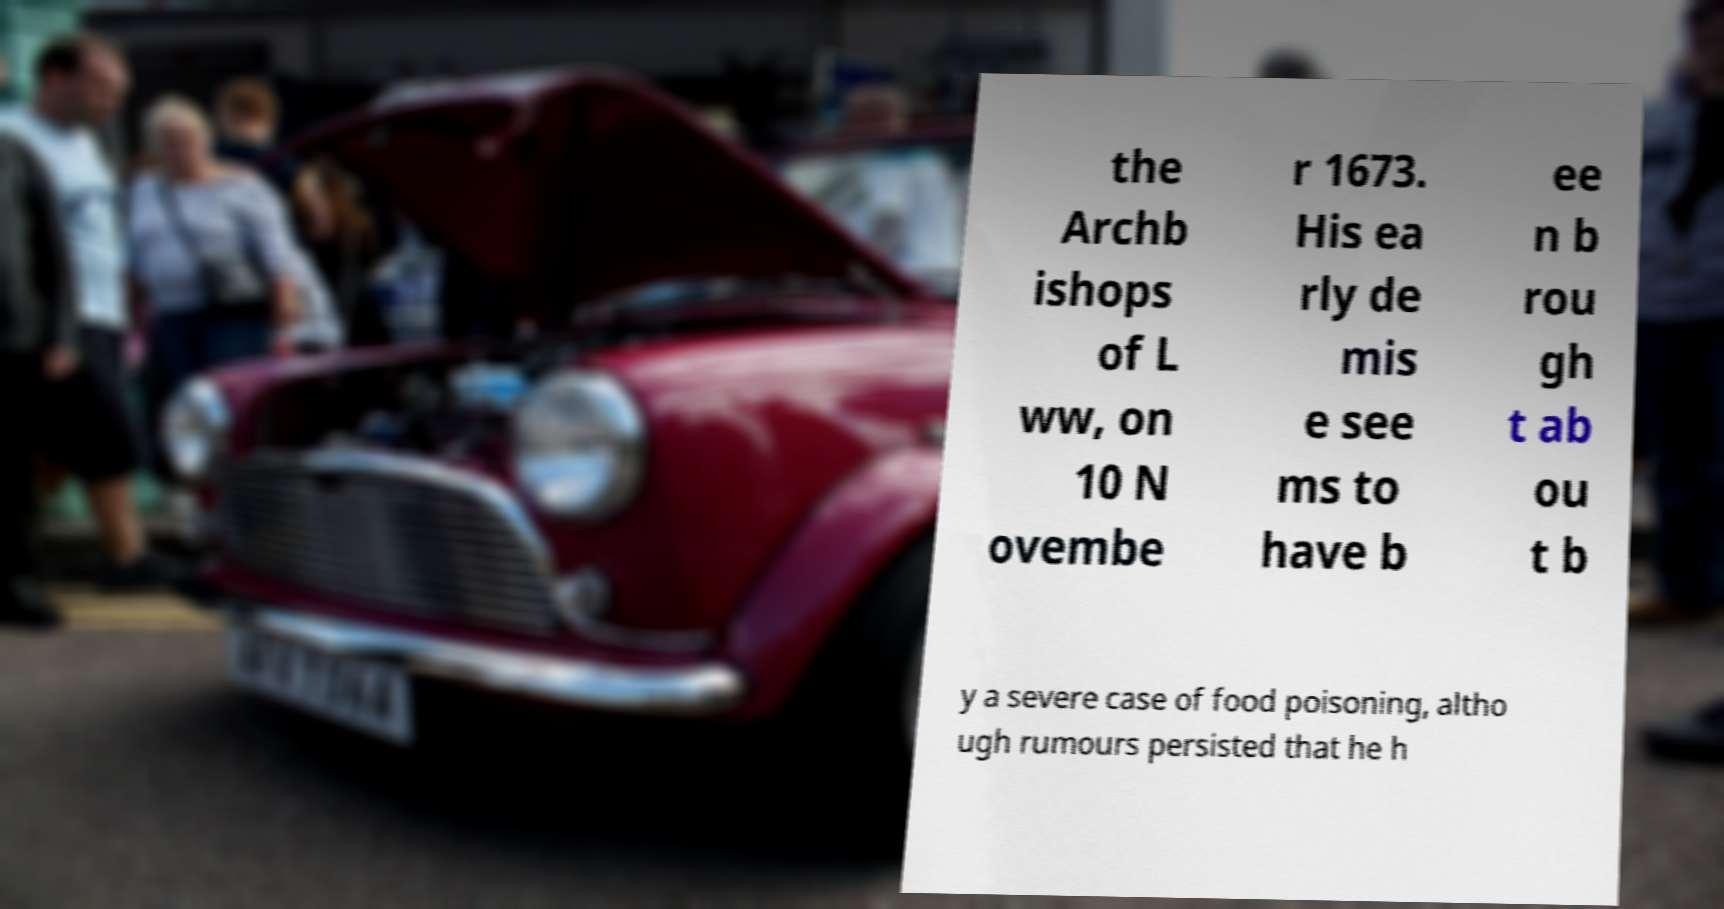Please read and relay the text visible in this image. What does it say? the Archb ishops of L ww, on 10 N ovembe r 1673. His ea rly de mis e see ms to have b ee n b rou gh t ab ou t b y a severe case of food poisoning, altho ugh rumours persisted that he h 